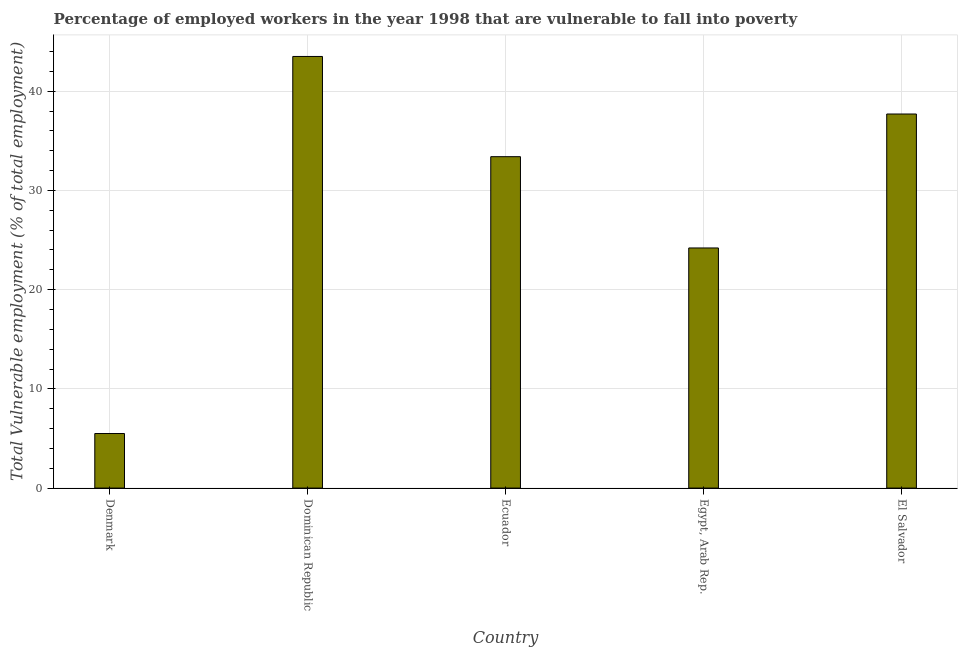What is the title of the graph?
Your answer should be very brief. Percentage of employed workers in the year 1998 that are vulnerable to fall into poverty. What is the label or title of the X-axis?
Your response must be concise. Country. What is the label or title of the Y-axis?
Offer a very short reply. Total Vulnerable employment (% of total employment). What is the total vulnerable employment in Egypt, Arab Rep.?
Your answer should be compact. 24.2. Across all countries, what is the maximum total vulnerable employment?
Keep it short and to the point. 43.5. Across all countries, what is the minimum total vulnerable employment?
Keep it short and to the point. 5.5. In which country was the total vulnerable employment maximum?
Provide a succinct answer. Dominican Republic. In which country was the total vulnerable employment minimum?
Provide a succinct answer. Denmark. What is the sum of the total vulnerable employment?
Ensure brevity in your answer.  144.3. What is the difference between the total vulnerable employment in Dominican Republic and Egypt, Arab Rep.?
Give a very brief answer. 19.3. What is the average total vulnerable employment per country?
Ensure brevity in your answer.  28.86. What is the median total vulnerable employment?
Keep it short and to the point. 33.4. What is the ratio of the total vulnerable employment in Ecuador to that in Egypt, Arab Rep.?
Your answer should be compact. 1.38. What is the difference between the highest and the lowest total vulnerable employment?
Provide a succinct answer. 38. How many bars are there?
Your answer should be very brief. 5. How many countries are there in the graph?
Provide a short and direct response. 5. What is the difference between two consecutive major ticks on the Y-axis?
Make the answer very short. 10. Are the values on the major ticks of Y-axis written in scientific E-notation?
Make the answer very short. No. What is the Total Vulnerable employment (% of total employment) of Denmark?
Your response must be concise. 5.5. What is the Total Vulnerable employment (% of total employment) of Dominican Republic?
Your answer should be compact. 43.5. What is the Total Vulnerable employment (% of total employment) of Ecuador?
Keep it short and to the point. 33.4. What is the Total Vulnerable employment (% of total employment) of Egypt, Arab Rep.?
Ensure brevity in your answer.  24.2. What is the Total Vulnerable employment (% of total employment) in El Salvador?
Ensure brevity in your answer.  37.7. What is the difference between the Total Vulnerable employment (% of total employment) in Denmark and Dominican Republic?
Your answer should be very brief. -38. What is the difference between the Total Vulnerable employment (% of total employment) in Denmark and Ecuador?
Make the answer very short. -27.9. What is the difference between the Total Vulnerable employment (% of total employment) in Denmark and Egypt, Arab Rep.?
Your answer should be compact. -18.7. What is the difference between the Total Vulnerable employment (% of total employment) in Denmark and El Salvador?
Your answer should be compact. -32.2. What is the difference between the Total Vulnerable employment (% of total employment) in Dominican Republic and Ecuador?
Offer a terse response. 10.1. What is the difference between the Total Vulnerable employment (% of total employment) in Dominican Republic and Egypt, Arab Rep.?
Provide a succinct answer. 19.3. What is the ratio of the Total Vulnerable employment (% of total employment) in Denmark to that in Dominican Republic?
Offer a very short reply. 0.13. What is the ratio of the Total Vulnerable employment (% of total employment) in Denmark to that in Ecuador?
Give a very brief answer. 0.17. What is the ratio of the Total Vulnerable employment (% of total employment) in Denmark to that in Egypt, Arab Rep.?
Your answer should be compact. 0.23. What is the ratio of the Total Vulnerable employment (% of total employment) in Denmark to that in El Salvador?
Your answer should be compact. 0.15. What is the ratio of the Total Vulnerable employment (% of total employment) in Dominican Republic to that in Ecuador?
Ensure brevity in your answer.  1.3. What is the ratio of the Total Vulnerable employment (% of total employment) in Dominican Republic to that in Egypt, Arab Rep.?
Offer a very short reply. 1.8. What is the ratio of the Total Vulnerable employment (% of total employment) in Dominican Republic to that in El Salvador?
Provide a succinct answer. 1.15. What is the ratio of the Total Vulnerable employment (% of total employment) in Ecuador to that in Egypt, Arab Rep.?
Provide a succinct answer. 1.38. What is the ratio of the Total Vulnerable employment (% of total employment) in Ecuador to that in El Salvador?
Your answer should be compact. 0.89. What is the ratio of the Total Vulnerable employment (% of total employment) in Egypt, Arab Rep. to that in El Salvador?
Give a very brief answer. 0.64. 